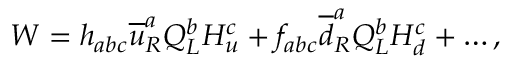Convert formula to latex. <formula><loc_0><loc_0><loc_500><loc_500>W = h _ { a b c } \overline { u } _ { R } ^ { a } Q _ { L } ^ { b } H _ { u } ^ { c } + f _ { a b c } \overline { d } _ { R } ^ { a } Q _ { L } ^ { b } H _ { d } ^ { c } + \dots ,</formula> 